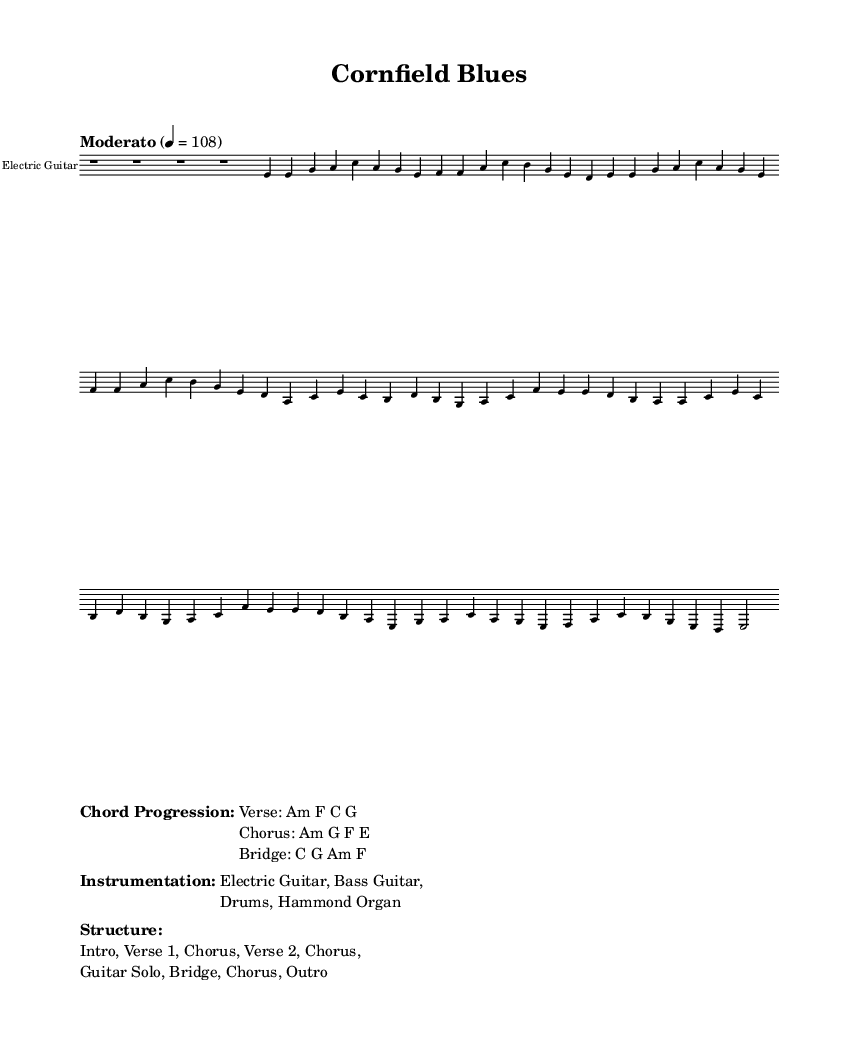What is the key signature of this music? The key signature is indicated by the notes present and specifies the pitches used in the piece. Here, the piece is in A minor, which has no sharps or flats.
Answer: A minor What is the time signature? The time signature is represented at the beginning of the score. In this case, it shows a 4/4 time signature, which means there are four beats in each measure, and the quarter note gets one beat.
Answer: 4/4 What is the tempo marking? The tempo is indicated at the beginning of the score with the term “Moderato,” along with the metronome marking of 4 = 108, which suggests a moderate pace at 108 beats per minute.
Answer: Moderato What instruments are featured in this piece? The instruments are listed in the score's markup section under "Instrumentation." They include Electric Guitar, Bass Guitar, Drums, and Hammond Organ.
Answer: Electric Guitar, Bass Guitar, Drums, Hammond Organ What is the chord progression for the verse? The chord progression is provided in the markup section labeled "Chord Progression." For the verse, it states the chords are Am, F, C, and G.
Answer: Am F C G How many sections does the song have? The structure of the song is outlined in the score under "Structure." It lists the sections present, which include Intro, Verse 1, Chorus, Verse 2, Guitar Solo, Bridge, and Outro, totaling eight sections.
Answer: Eight sections What style of music does this piece represent? The title of the piece and the influences in the chord structure suggest it falls under a specific genre. Given its bluesy themes, instrumentation, and structure, it is categorized as a contemporary blues-rock fusion.
Answer: Contemporary blues-rock fusion 